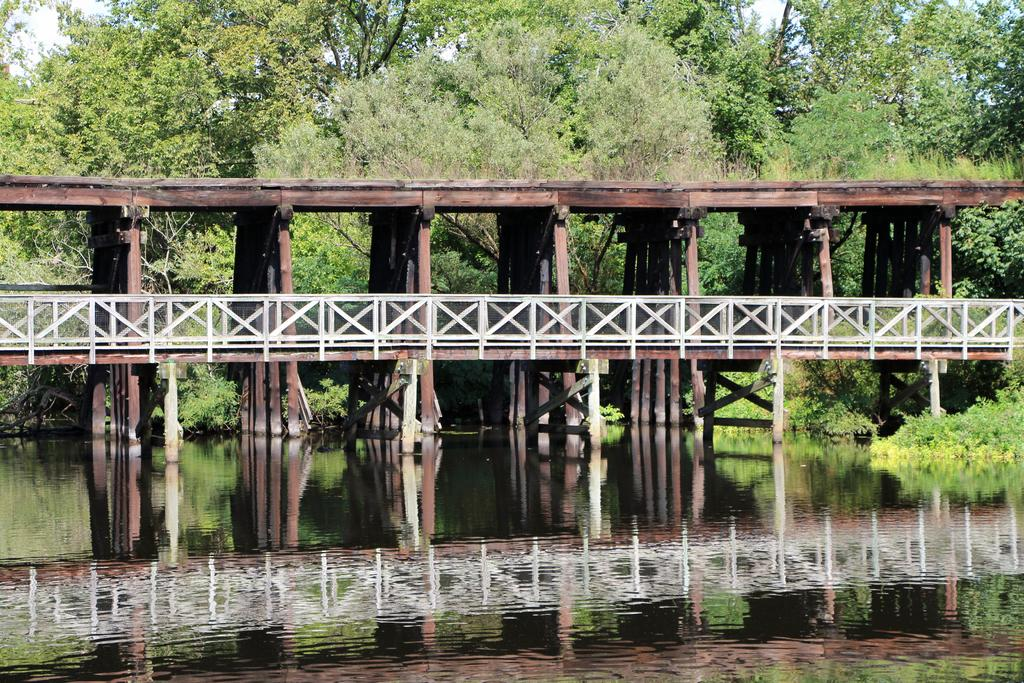What type of structure is present in the image? There is a wooden bridge in the image. What is the appearance of the bridge's railing? The bridge has a white fencing railing. What can be seen in the background of the image? There are trees visible in the background of the image. What is located at the front bottom side of the image? There is river water in the front bottom side of the image. How many chickens are sitting on the bridge in the image? There are no chickens present in the image. Is there a bathtub visible in the image? There is no bathtub present in the image. 